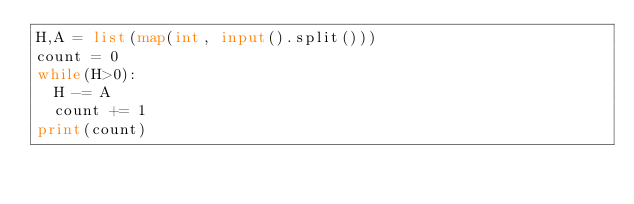Convert code to text. <code><loc_0><loc_0><loc_500><loc_500><_Python_>H,A = list(map(int, input().split()))
count = 0
while(H>0):
  H -= A
  count += 1
print(count)</code> 